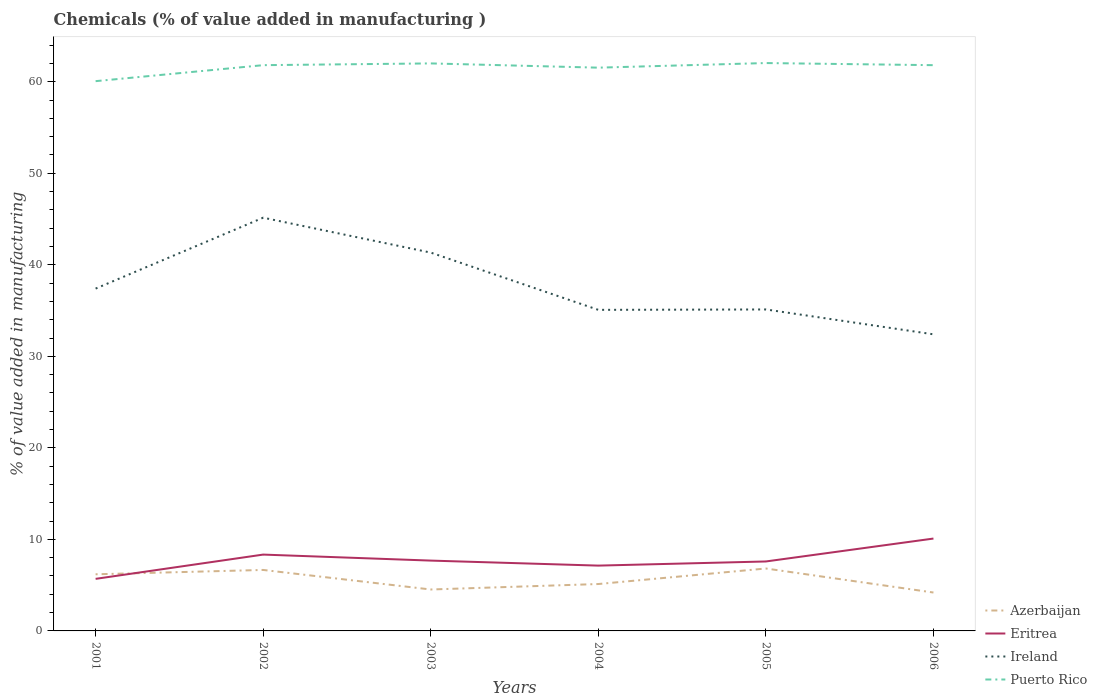How many different coloured lines are there?
Give a very brief answer. 4. Is the number of lines equal to the number of legend labels?
Provide a short and direct response. Yes. Across all years, what is the maximum value added in manufacturing chemicals in Puerto Rico?
Offer a very short reply. 60.06. In which year was the value added in manufacturing chemicals in Puerto Rico maximum?
Offer a terse response. 2001. What is the total value added in manufacturing chemicals in Eritrea in the graph?
Offer a terse response. -2.41. What is the difference between the highest and the second highest value added in manufacturing chemicals in Ireland?
Offer a very short reply. 12.74. Is the value added in manufacturing chemicals in Eritrea strictly greater than the value added in manufacturing chemicals in Ireland over the years?
Offer a terse response. Yes. How many lines are there?
Offer a terse response. 4. Are the values on the major ticks of Y-axis written in scientific E-notation?
Make the answer very short. No. Does the graph contain grids?
Ensure brevity in your answer.  No. Where does the legend appear in the graph?
Your response must be concise. Bottom right. How many legend labels are there?
Make the answer very short. 4. How are the legend labels stacked?
Your response must be concise. Vertical. What is the title of the graph?
Make the answer very short. Chemicals (% of value added in manufacturing ). What is the label or title of the Y-axis?
Give a very brief answer. % of value added in manufacturing. What is the % of value added in manufacturing of Azerbaijan in 2001?
Make the answer very short. 6.19. What is the % of value added in manufacturing in Eritrea in 2001?
Keep it short and to the point. 5.69. What is the % of value added in manufacturing of Ireland in 2001?
Your answer should be very brief. 37.4. What is the % of value added in manufacturing in Puerto Rico in 2001?
Offer a terse response. 60.06. What is the % of value added in manufacturing of Azerbaijan in 2002?
Your answer should be very brief. 6.66. What is the % of value added in manufacturing of Eritrea in 2002?
Give a very brief answer. 8.34. What is the % of value added in manufacturing in Ireland in 2002?
Your answer should be compact. 45.14. What is the % of value added in manufacturing of Puerto Rico in 2002?
Provide a short and direct response. 61.81. What is the % of value added in manufacturing of Azerbaijan in 2003?
Provide a short and direct response. 4.53. What is the % of value added in manufacturing in Eritrea in 2003?
Provide a succinct answer. 7.68. What is the % of value added in manufacturing of Ireland in 2003?
Offer a very short reply. 41.33. What is the % of value added in manufacturing of Puerto Rico in 2003?
Keep it short and to the point. 62. What is the % of value added in manufacturing in Azerbaijan in 2004?
Give a very brief answer. 5.12. What is the % of value added in manufacturing of Eritrea in 2004?
Keep it short and to the point. 7.14. What is the % of value added in manufacturing of Ireland in 2004?
Provide a succinct answer. 35.08. What is the % of value added in manufacturing in Puerto Rico in 2004?
Your answer should be very brief. 61.53. What is the % of value added in manufacturing of Azerbaijan in 2005?
Keep it short and to the point. 6.82. What is the % of value added in manufacturing in Eritrea in 2005?
Provide a short and direct response. 7.59. What is the % of value added in manufacturing in Ireland in 2005?
Ensure brevity in your answer.  35.12. What is the % of value added in manufacturing in Puerto Rico in 2005?
Ensure brevity in your answer.  62.04. What is the % of value added in manufacturing in Azerbaijan in 2006?
Keep it short and to the point. 4.2. What is the % of value added in manufacturing in Eritrea in 2006?
Offer a very short reply. 10.09. What is the % of value added in manufacturing of Ireland in 2006?
Your response must be concise. 32.4. What is the % of value added in manufacturing of Puerto Rico in 2006?
Your response must be concise. 61.81. Across all years, what is the maximum % of value added in manufacturing in Azerbaijan?
Offer a very short reply. 6.82. Across all years, what is the maximum % of value added in manufacturing in Eritrea?
Give a very brief answer. 10.09. Across all years, what is the maximum % of value added in manufacturing in Ireland?
Your response must be concise. 45.14. Across all years, what is the maximum % of value added in manufacturing of Puerto Rico?
Make the answer very short. 62.04. Across all years, what is the minimum % of value added in manufacturing of Azerbaijan?
Give a very brief answer. 4.2. Across all years, what is the minimum % of value added in manufacturing in Eritrea?
Make the answer very short. 5.69. Across all years, what is the minimum % of value added in manufacturing in Ireland?
Make the answer very short. 32.4. Across all years, what is the minimum % of value added in manufacturing in Puerto Rico?
Your answer should be very brief. 60.06. What is the total % of value added in manufacturing in Azerbaijan in the graph?
Your answer should be very brief. 33.51. What is the total % of value added in manufacturing in Eritrea in the graph?
Give a very brief answer. 46.53. What is the total % of value added in manufacturing of Ireland in the graph?
Your response must be concise. 226.47. What is the total % of value added in manufacturing of Puerto Rico in the graph?
Offer a terse response. 369.25. What is the difference between the % of value added in manufacturing in Azerbaijan in 2001 and that in 2002?
Provide a short and direct response. -0.47. What is the difference between the % of value added in manufacturing of Eritrea in 2001 and that in 2002?
Ensure brevity in your answer.  -2.65. What is the difference between the % of value added in manufacturing of Ireland in 2001 and that in 2002?
Keep it short and to the point. -7.75. What is the difference between the % of value added in manufacturing in Puerto Rico in 2001 and that in 2002?
Your answer should be very brief. -1.75. What is the difference between the % of value added in manufacturing of Azerbaijan in 2001 and that in 2003?
Offer a terse response. 1.66. What is the difference between the % of value added in manufacturing of Eritrea in 2001 and that in 2003?
Make the answer very short. -2. What is the difference between the % of value added in manufacturing of Ireland in 2001 and that in 2003?
Offer a terse response. -3.93. What is the difference between the % of value added in manufacturing of Puerto Rico in 2001 and that in 2003?
Give a very brief answer. -1.94. What is the difference between the % of value added in manufacturing of Azerbaijan in 2001 and that in 2004?
Ensure brevity in your answer.  1.06. What is the difference between the % of value added in manufacturing in Eritrea in 2001 and that in 2004?
Your answer should be very brief. -1.45. What is the difference between the % of value added in manufacturing of Ireland in 2001 and that in 2004?
Make the answer very short. 2.32. What is the difference between the % of value added in manufacturing of Puerto Rico in 2001 and that in 2004?
Keep it short and to the point. -1.47. What is the difference between the % of value added in manufacturing of Azerbaijan in 2001 and that in 2005?
Offer a terse response. -0.63. What is the difference between the % of value added in manufacturing of Eritrea in 2001 and that in 2005?
Make the answer very short. -1.9. What is the difference between the % of value added in manufacturing in Ireland in 2001 and that in 2005?
Make the answer very short. 2.28. What is the difference between the % of value added in manufacturing of Puerto Rico in 2001 and that in 2005?
Offer a terse response. -1.98. What is the difference between the % of value added in manufacturing of Azerbaijan in 2001 and that in 2006?
Make the answer very short. 1.99. What is the difference between the % of value added in manufacturing of Eritrea in 2001 and that in 2006?
Offer a terse response. -4.4. What is the difference between the % of value added in manufacturing in Ireland in 2001 and that in 2006?
Keep it short and to the point. 5. What is the difference between the % of value added in manufacturing in Puerto Rico in 2001 and that in 2006?
Provide a short and direct response. -1.75. What is the difference between the % of value added in manufacturing of Azerbaijan in 2002 and that in 2003?
Your response must be concise. 2.14. What is the difference between the % of value added in manufacturing in Eritrea in 2002 and that in 2003?
Offer a terse response. 0.66. What is the difference between the % of value added in manufacturing in Ireland in 2002 and that in 2003?
Keep it short and to the point. 3.81. What is the difference between the % of value added in manufacturing of Puerto Rico in 2002 and that in 2003?
Your answer should be very brief. -0.19. What is the difference between the % of value added in manufacturing in Azerbaijan in 2002 and that in 2004?
Make the answer very short. 1.54. What is the difference between the % of value added in manufacturing of Eritrea in 2002 and that in 2004?
Ensure brevity in your answer.  1.2. What is the difference between the % of value added in manufacturing in Ireland in 2002 and that in 2004?
Make the answer very short. 10.07. What is the difference between the % of value added in manufacturing in Puerto Rico in 2002 and that in 2004?
Your answer should be very brief. 0.27. What is the difference between the % of value added in manufacturing in Azerbaijan in 2002 and that in 2005?
Keep it short and to the point. -0.16. What is the difference between the % of value added in manufacturing of Eritrea in 2002 and that in 2005?
Make the answer very short. 0.75. What is the difference between the % of value added in manufacturing in Ireland in 2002 and that in 2005?
Give a very brief answer. 10.03. What is the difference between the % of value added in manufacturing of Puerto Rico in 2002 and that in 2005?
Give a very brief answer. -0.23. What is the difference between the % of value added in manufacturing in Azerbaijan in 2002 and that in 2006?
Ensure brevity in your answer.  2.47. What is the difference between the % of value added in manufacturing of Eritrea in 2002 and that in 2006?
Provide a succinct answer. -1.75. What is the difference between the % of value added in manufacturing of Ireland in 2002 and that in 2006?
Your answer should be compact. 12.74. What is the difference between the % of value added in manufacturing of Puerto Rico in 2002 and that in 2006?
Provide a succinct answer. 0. What is the difference between the % of value added in manufacturing of Azerbaijan in 2003 and that in 2004?
Give a very brief answer. -0.6. What is the difference between the % of value added in manufacturing in Eritrea in 2003 and that in 2004?
Offer a terse response. 0.55. What is the difference between the % of value added in manufacturing in Ireland in 2003 and that in 2004?
Offer a very short reply. 6.25. What is the difference between the % of value added in manufacturing in Puerto Rico in 2003 and that in 2004?
Your answer should be compact. 0.46. What is the difference between the % of value added in manufacturing in Azerbaijan in 2003 and that in 2005?
Give a very brief answer. -2.29. What is the difference between the % of value added in manufacturing of Eritrea in 2003 and that in 2005?
Make the answer very short. 0.1. What is the difference between the % of value added in manufacturing in Ireland in 2003 and that in 2005?
Your answer should be compact. 6.21. What is the difference between the % of value added in manufacturing of Puerto Rico in 2003 and that in 2005?
Offer a terse response. -0.04. What is the difference between the % of value added in manufacturing of Azerbaijan in 2003 and that in 2006?
Your answer should be compact. 0.33. What is the difference between the % of value added in manufacturing of Eritrea in 2003 and that in 2006?
Provide a succinct answer. -2.41. What is the difference between the % of value added in manufacturing in Ireland in 2003 and that in 2006?
Make the answer very short. 8.93. What is the difference between the % of value added in manufacturing in Puerto Rico in 2003 and that in 2006?
Provide a succinct answer. 0.19. What is the difference between the % of value added in manufacturing of Azerbaijan in 2004 and that in 2005?
Your response must be concise. -1.7. What is the difference between the % of value added in manufacturing in Eritrea in 2004 and that in 2005?
Ensure brevity in your answer.  -0.45. What is the difference between the % of value added in manufacturing in Ireland in 2004 and that in 2005?
Ensure brevity in your answer.  -0.04. What is the difference between the % of value added in manufacturing in Puerto Rico in 2004 and that in 2005?
Ensure brevity in your answer.  -0.5. What is the difference between the % of value added in manufacturing of Azerbaijan in 2004 and that in 2006?
Offer a very short reply. 0.93. What is the difference between the % of value added in manufacturing in Eritrea in 2004 and that in 2006?
Ensure brevity in your answer.  -2.96. What is the difference between the % of value added in manufacturing in Ireland in 2004 and that in 2006?
Your response must be concise. 2.67. What is the difference between the % of value added in manufacturing in Puerto Rico in 2004 and that in 2006?
Make the answer very short. -0.27. What is the difference between the % of value added in manufacturing in Azerbaijan in 2005 and that in 2006?
Your response must be concise. 2.62. What is the difference between the % of value added in manufacturing of Eritrea in 2005 and that in 2006?
Your answer should be compact. -2.5. What is the difference between the % of value added in manufacturing of Ireland in 2005 and that in 2006?
Keep it short and to the point. 2.72. What is the difference between the % of value added in manufacturing in Puerto Rico in 2005 and that in 2006?
Give a very brief answer. 0.23. What is the difference between the % of value added in manufacturing of Azerbaijan in 2001 and the % of value added in manufacturing of Eritrea in 2002?
Your answer should be very brief. -2.15. What is the difference between the % of value added in manufacturing in Azerbaijan in 2001 and the % of value added in manufacturing in Ireland in 2002?
Your response must be concise. -38.96. What is the difference between the % of value added in manufacturing in Azerbaijan in 2001 and the % of value added in manufacturing in Puerto Rico in 2002?
Ensure brevity in your answer.  -55.62. What is the difference between the % of value added in manufacturing of Eritrea in 2001 and the % of value added in manufacturing of Ireland in 2002?
Your answer should be compact. -39.46. What is the difference between the % of value added in manufacturing of Eritrea in 2001 and the % of value added in manufacturing of Puerto Rico in 2002?
Ensure brevity in your answer.  -56.12. What is the difference between the % of value added in manufacturing in Ireland in 2001 and the % of value added in manufacturing in Puerto Rico in 2002?
Provide a short and direct response. -24.41. What is the difference between the % of value added in manufacturing of Azerbaijan in 2001 and the % of value added in manufacturing of Eritrea in 2003?
Provide a short and direct response. -1.5. What is the difference between the % of value added in manufacturing of Azerbaijan in 2001 and the % of value added in manufacturing of Ireland in 2003?
Provide a short and direct response. -35.14. What is the difference between the % of value added in manufacturing of Azerbaijan in 2001 and the % of value added in manufacturing of Puerto Rico in 2003?
Your answer should be compact. -55.81. What is the difference between the % of value added in manufacturing of Eritrea in 2001 and the % of value added in manufacturing of Ireland in 2003?
Your answer should be very brief. -35.64. What is the difference between the % of value added in manufacturing in Eritrea in 2001 and the % of value added in manufacturing in Puerto Rico in 2003?
Provide a succinct answer. -56.31. What is the difference between the % of value added in manufacturing in Ireland in 2001 and the % of value added in manufacturing in Puerto Rico in 2003?
Your response must be concise. -24.6. What is the difference between the % of value added in manufacturing of Azerbaijan in 2001 and the % of value added in manufacturing of Eritrea in 2004?
Offer a very short reply. -0.95. What is the difference between the % of value added in manufacturing in Azerbaijan in 2001 and the % of value added in manufacturing in Ireland in 2004?
Offer a very short reply. -28.89. What is the difference between the % of value added in manufacturing of Azerbaijan in 2001 and the % of value added in manufacturing of Puerto Rico in 2004?
Your answer should be compact. -55.35. What is the difference between the % of value added in manufacturing of Eritrea in 2001 and the % of value added in manufacturing of Ireland in 2004?
Provide a short and direct response. -29.39. What is the difference between the % of value added in manufacturing of Eritrea in 2001 and the % of value added in manufacturing of Puerto Rico in 2004?
Your answer should be compact. -55.85. What is the difference between the % of value added in manufacturing of Ireland in 2001 and the % of value added in manufacturing of Puerto Rico in 2004?
Your answer should be very brief. -24.14. What is the difference between the % of value added in manufacturing of Azerbaijan in 2001 and the % of value added in manufacturing of Eritrea in 2005?
Make the answer very short. -1.4. What is the difference between the % of value added in manufacturing of Azerbaijan in 2001 and the % of value added in manufacturing of Ireland in 2005?
Your answer should be very brief. -28.93. What is the difference between the % of value added in manufacturing in Azerbaijan in 2001 and the % of value added in manufacturing in Puerto Rico in 2005?
Your answer should be very brief. -55.85. What is the difference between the % of value added in manufacturing in Eritrea in 2001 and the % of value added in manufacturing in Ireland in 2005?
Your response must be concise. -29.43. What is the difference between the % of value added in manufacturing in Eritrea in 2001 and the % of value added in manufacturing in Puerto Rico in 2005?
Give a very brief answer. -56.35. What is the difference between the % of value added in manufacturing of Ireland in 2001 and the % of value added in manufacturing of Puerto Rico in 2005?
Your response must be concise. -24.64. What is the difference between the % of value added in manufacturing in Azerbaijan in 2001 and the % of value added in manufacturing in Eritrea in 2006?
Make the answer very short. -3.9. What is the difference between the % of value added in manufacturing of Azerbaijan in 2001 and the % of value added in manufacturing of Ireland in 2006?
Ensure brevity in your answer.  -26.21. What is the difference between the % of value added in manufacturing of Azerbaijan in 2001 and the % of value added in manufacturing of Puerto Rico in 2006?
Make the answer very short. -55.62. What is the difference between the % of value added in manufacturing of Eritrea in 2001 and the % of value added in manufacturing of Ireland in 2006?
Your answer should be compact. -26.71. What is the difference between the % of value added in manufacturing of Eritrea in 2001 and the % of value added in manufacturing of Puerto Rico in 2006?
Offer a terse response. -56.12. What is the difference between the % of value added in manufacturing in Ireland in 2001 and the % of value added in manufacturing in Puerto Rico in 2006?
Offer a terse response. -24.41. What is the difference between the % of value added in manufacturing in Azerbaijan in 2002 and the % of value added in manufacturing in Eritrea in 2003?
Provide a short and direct response. -1.02. What is the difference between the % of value added in manufacturing of Azerbaijan in 2002 and the % of value added in manufacturing of Ireland in 2003?
Ensure brevity in your answer.  -34.67. What is the difference between the % of value added in manufacturing in Azerbaijan in 2002 and the % of value added in manufacturing in Puerto Rico in 2003?
Your answer should be very brief. -55.34. What is the difference between the % of value added in manufacturing in Eritrea in 2002 and the % of value added in manufacturing in Ireland in 2003?
Provide a succinct answer. -32.99. What is the difference between the % of value added in manufacturing of Eritrea in 2002 and the % of value added in manufacturing of Puerto Rico in 2003?
Provide a short and direct response. -53.66. What is the difference between the % of value added in manufacturing in Ireland in 2002 and the % of value added in manufacturing in Puerto Rico in 2003?
Offer a very short reply. -16.85. What is the difference between the % of value added in manufacturing of Azerbaijan in 2002 and the % of value added in manufacturing of Eritrea in 2004?
Your response must be concise. -0.47. What is the difference between the % of value added in manufacturing of Azerbaijan in 2002 and the % of value added in manufacturing of Ireland in 2004?
Provide a succinct answer. -28.41. What is the difference between the % of value added in manufacturing of Azerbaijan in 2002 and the % of value added in manufacturing of Puerto Rico in 2004?
Give a very brief answer. -54.87. What is the difference between the % of value added in manufacturing in Eritrea in 2002 and the % of value added in manufacturing in Ireland in 2004?
Ensure brevity in your answer.  -26.74. What is the difference between the % of value added in manufacturing of Eritrea in 2002 and the % of value added in manufacturing of Puerto Rico in 2004?
Make the answer very short. -53.2. What is the difference between the % of value added in manufacturing of Ireland in 2002 and the % of value added in manufacturing of Puerto Rico in 2004?
Your answer should be compact. -16.39. What is the difference between the % of value added in manufacturing in Azerbaijan in 2002 and the % of value added in manufacturing in Eritrea in 2005?
Ensure brevity in your answer.  -0.93. What is the difference between the % of value added in manufacturing in Azerbaijan in 2002 and the % of value added in manufacturing in Ireland in 2005?
Ensure brevity in your answer.  -28.46. What is the difference between the % of value added in manufacturing in Azerbaijan in 2002 and the % of value added in manufacturing in Puerto Rico in 2005?
Offer a very short reply. -55.38. What is the difference between the % of value added in manufacturing in Eritrea in 2002 and the % of value added in manufacturing in Ireland in 2005?
Ensure brevity in your answer.  -26.78. What is the difference between the % of value added in manufacturing in Eritrea in 2002 and the % of value added in manufacturing in Puerto Rico in 2005?
Ensure brevity in your answer.  -53.7. What is the difference between the % of value added in manufacturing in Ireland in 2002 and the % of value added in manufacturing in Puerto Rico in 2005?
Ensure brevity in your answer.  -16.89. What is the difference between the % of value added in manufacturing in Azerbaijan in 2002 and the % of value added in manufacturing in Eritrea in 2006?
Keep it short and to the point. -3.43. What is the difference between the % of value added in manufacturing in Azerbaijan in 2002 and the % of value added in manufacturing in Ireland in 2006?
Provide a succinct answer. -25.74. What is the difference between the % of value added in manufacturing in Azerbaijan in 2002 and the % of value added in manufacturing in Puerto Rico in 2006?
Ensure brevity in your answer.  -55.15. What is the difference between the % of value added in manufacturing in Eritrea in 2002 and the % of value added in manufacturing in Ireland in 2006?
Give a very brief answer. -24.06. What is the difference between the % of value added in manufacturing of Eritrea in 2002 and the % of value added in manufacturing of Puerto Rico in 2006?
Provide a short and direct response. -53.47. What is the difference between the % of value added in manufacturing of Ireland in 2002 and the % of value added in manufacturing of Puerto Rico in 2006?
Make the answer very short. -16.66. What is the difference between the % of value added in manufacturing of Azerbaijan in 2003 and the % of value added in manufacturing of Eritrea in 2004?
Offer a terse response. -2.61. What is the difference between the % of value added in manufacturing in Azerbaijan in 2003 and the % of value added in manufacturing in Ireland in 2004?
Provide a succinct answer. -30.55. What is the difference between the % of value added in manufacturing of Azerbaijan in 2003 and the % of value added in manufacturing of Puerto Rico in 2004?
Your answer should be very brief. -57.01. What is the difference between the % of value added in manufacturing in Eritrea in 2003 and the % of value added in manufacturing in Ireland in 2004?
Provide a succinct answer. -27.39. What is the difference between the % of value added in manufacturing in Eritrea in 2003 and the % of value added in manufacturing in Puerto Rico in 2004?
Keep it short and to the point. -53.85. What is the difference between the % of value added in manufacturing in Ireland in 2003 and the % of value added in manufacturing in Puerto Rico in 2004?
Provide a short and direct response. -20.2. What is the difference between the % of value added in manufacturing in Azerbaijan in 2003 and the % of value added in manufacturing in Eritrea in 2005?
Provide a succinct answer. -3.06. What is the difference between the % of value added in manufacturing in Azerbaijan in 2003 and the % of value added in manufacturing in Ireland in 2005?
Your answer should be very brief. -30.59. What is the difference between the % of value added in manufacturing in Azerbaijan in 2003 and the % of value added in manufacturing in Puerto Rico in 2005?
Offer a very short reply. -57.51. What is the difference between the % of value added in manufacturing of Eritrea in 2003 and the % of value added in manufacturing of Ireland in 2005?
Ensure brevity in your answer.  -27.44. What is the difference between the % of value added in manufacturing in Eritrea in 2003 and the % of value added in manufacturing in Puerto Rico in 2005?
Your answer should be compact. -54.35. What is the difference between the % of value added in manufacturing of Ireland in 2003 and the % of value added in manufacturing of Puerto Rico in 2005?
Offer a very short reply. -20.71. What is the difference between the % of value added in manufacturing in Azerbaijan in 2003 and the % of value added in manufacturing in Eritrea in 2006?
Your answer should be very brief. -5.57. What is the difference between the % of value added in manufacturing in Azerbaijan in 2003 and the % of value added in manufacturing in Ireland in 2006?
Provide a short and direct response. -27.88. What is the difference between the % of value added in manufacturing in Azerbaijan in 2003 and the % of value added in manufacturing in Puerto Rico in 2006?
Ensure brevity in your answer.  -57.28. What is the difference between the % of value added in manufacturing in Eritrea in 2003 and the % of value added in manufacturing in Ireland in 2006?
Make the answer very short. -24.72. What is the difference between the % of value added in manufacturing in Eritrea in 2003 and the % of value added in manufacturing in Puerto Rico in 2006?
Offer a terse response. -54.12. What is the difference between the % of value added in manufacturing of Ireland in 2003 and the % of value added in manufacturing of Puerto Rico in 2006?
Your answer should be compact. -20.48. What is the difference between the % of value added in manufacturing in Azerbaijan in 2004 and the % of value added in manufacturing in Eritrea in 2005?
Give a very brief answer. -2.46. What is the difference between the % of value added in manufacturing in Azerbaijan in 2004 and the % of value added in manufacturing in Ireland in 2005?
Keep it short and to the point. -30. What is the difference between the % of value added in manufacturing of Azerbaijan in 2004 and the % of value added in manufacturing of Puerto Rico in 2005?
Your answer should be compact. -56.92. What is the difference between the % of value added in manufacturing of Eritrea in 2004 and the % of value added in manufacturing of Ireland in 2005?
Your answer should be compact. -27.98. What is the difference between the % of value added in manufacturing of Eritrea in 2004 and the % of value added in manufacturing of Puerto Rico in 2005?
Your answer should be very brief. -54.9. What is the difference between the % of value added in manufacturing in Ireland in 2004 and the % of value added in manufacturing in Puerto Rico in 2005?
Give a very brief answer. -26.96. What is the difference between the % of value added in manufacturing in Azerbaijan in 2004 and the % of value added in manufacturing in Eritrea in 2006?
Offer a terse response. -4.97. What is the difference between the % of value added in manufacturing of Azerbaijan in 2004 and the % of value added in manufacturing of Ireland in 2006?
Your answer should be compact. -27.28. What is the difference between the % of value added in manufacturing of Azerbaijan in 2004 and the % of value added in manufacturing of Puerto Rico in 2006?
Make the answer very short. -56.68. What is the difference between the % of value added in manufacturing of Eritrea in 2004 and the % of value added in manufacturing of Ireland in 2006?
Give a very brief answer. -25.27. What is the difference between the % of value added in manufacturing in Eritrea in 2004 and the % of value added in manufacturing in Puerto Rico in 2006?
Your response must be concise. -54.67. What is the difference between the % of value added in manufacturing of Ireland in 2004 and the % of value added in manufacturing of Puerto Rico in 2006?
Give a very brief answer. -26.73. What is the difference between the % of value added in manufacturing of Azerbaijan in 2005 and the % of value added in manufacturing of Eritrea in 2006?
Provide a short and direct response. -3.27. What is the difference between the % of value added in manufacturing in Azerbaijan in 2005 and the % of value added in manufacturing in Ireland in 2006?
Your answer should be compact. -25.58. What is the difference between the % of value added in manufacturing of Azerbaijan in 2005 and the % of value added in manufacturing of Puerto Rico in 2006?
Your answer should be very brief. -54.99. What is the difference between the % of value added in manufacturing in Eritrea in 2005 and the % of value added in manufacturing in Ireland in 2006?
Give a very brief answer. -24.81. What is the difference between the % of value added in manufacturing in Eritrea in 2005 and the % of value added in manufacturing in Puerto Rico in 2006?
Your answer should be compact. -54.22. What is the difference between the % of value added in manufacturing of Ireland in 2005 and the % of value added in manufacturing of Puerto Rico in 2006?
Provide a succinct answer. -26.69. What is the average % of value added in manufacturing of Azerbaijan per year?
Your answer should be compact. 5.59. What is the average % of value added in manufacturing in Eritrea per year?
Keep it short and to the point. 7.75. What is the average % of value added in manufacturing of Ireland per year?
Your response must be concise. 37.75. What is the average % of value added in manufacturing in Puerto Rico per year?
Your answer should be very brief. 61.54. In the year 2001, what is the difference between the % of value added in manufacturing in Azerbaijan and % of value added in manufacturing in Eritrea?
Keep it short and to the point. 0.5. In the year 2001, what is the difference between the % of value added in manufacturing of Azerbaijan and % of value added in manufacturing of Ireland?
Your response must be concise. -31.21. In the year 2001, what is the difference between the % of value added in manufacturing of Azerbaijan and % of value added in manufacturing of Puerto Rico?
Provide a succinct answer. -53.87. In the year 2001, what is the difference between the % of value added in manufacturing in Eritrea and % of value added in manufacturing in Ireland?
Offer a terse response. -31.71. In the year 2001, what is the difference between the % of value added in manufacturing in Eritrea and % of value added in manufacturing in Puerto Rico?
Give a very brief answer. -54.37. In the year 2001, what is the difference between the % of value added in manufacturing of Ireland and % of value added in manufacturing of Puerto Rico?
Offer a terse response. -22.66. In the year 2002, what is the difference between the % of value added in manufacturing of Azerbaijan and % of value added in manufacturing of Eritrea?
Give a very brief answer. -1.68. In the year 2002, what is the difference between the % of value added in manufacturing in Azerbaijan and % of value added in manufacturing in Ireland?
Provide a succinct answer. -38.48. In the year 2002, what is the difference between the % of value added in manufacturing in Azerbaijan and % of value added in manufacturing in Puerto Rico?
Offer a very short reply. -55.15. In the year 2002, what is the difference between the % of value added in manufacturing of Eritrea and % of value added in manufacturing of Ireland?
Make the answer very short. -36.8. In the year 2002, what is the difference between the % of value added in manufacturing in Eritrea and % of value added in manufacturing in Puerto Rico?
Provide a short and direct response. -53.47. In the year 2002, what is the difference between the % of value added in manufacturing in Ireland and % of value added in manufacturing in Puerto Rico?
Your answer should be very brief. -16.66. In the year 2003, what is the difference between the % of value added in manufacturing of Azerbaijan and % of value added in manufacturing of Eritrea?
Make the answer very short. -3.16. In the year 2003, what is the difference between the % of value added in manufacturing of Azerbaijan and % of value added in manufacturing of Ireland?
Provide a short and direct response. -36.8. In the year 2003, what is the difference between the % of value added in manufacturing of Azerbaijan and % of value added in manufacturing of Puerto Rico?
Make the answer very short. -57.47. In the year 2003, what is the difference between the % of value added in manufacturing of Eritrea and % of value added in manufacturing of Ireland?
Make the answer very short. -33.65. In the year 2003, what is the difference between the % of value added in manufacturing in Eritrea and % of value added in manufacturing in Puerto Rico?
Provide a short and direct response. -54.32. In the year 2003, what is the difference between the % of value added in manufacturing of Ireland and % of value added in manufacturing of Puerto Rico?
Offer a very short reply. -20.67. In the year 2004, what is the difference between the % of value added in manufacturing in Azerbaijan and % of value added in manufacturing in Eritrea?
Provide a short and direct response. -2.01. In the year 2004, what is the difference between the % of value added in manufacturing of Azerbaijan and % of value added in manufacturing of Ireland?
Provide a short and direct response. -29.95. In the year 2004, what is the difference between the % of value added in manufacturing of Azerbaijan and % of value added in manufacturing of Puerto Rico?
Your answer should be very brief. -56.41. In the year 2004, what is the difference between the % of value added in manufacturing in Eritrea and % of value added in manufacturing in Ireland?
Keep it short and to the point. -27.94. In the year 2004, what is the difference between the % of value added in manufacturing in Eritrea and % of value added in manufacturing in Puerto Rico?
Offer a very short reply. -54.4. In the year 2004, what is the difference between the % of value added in manufacturing in Ireland and % of value added in manufacturing in Puerto Rico?
Keep it short and to the point. -26.46. In the year 2005, what is the difference between the % of value added in manufacturing of Azerbaijan and % of value added in manufacturing of Eritrea?
Your response must be concise. -0.77. In the year 2005, what is the difference between the % of value added in manufacturing of Azerbaijan and % of value added in manufacturing of Ireland?
Ensure brevity in your answer.  -28.3. In the year 2005, what is the difference between the % of value added in manufacturing in Azerbaijan and % of value added in manufacturing in Puerto Rico?
Provide a short and direct response. -55.22. In the year 2005, what is the difference between the % of value added in manufacturing in Eritrea and % of value added in manufacturing in Ireland?
Make the answer very short. -27.53. In the year 2005, what is the difference between the % of value added in manufacturing of Eritrea and % of value added in manufacturing of Puerto Rico?
Ensure brevity in your answer.  -54.45. In the year 2005, what is the difference between the % of value added in manufacturing in Ireland and % of value added in manufacturing in Puerto Rico?
Make the answer very short. -26.92. In the year 2006, what is the difference between the % of value added in manufacturing of Azerbaijan and % of value added in manufacturing of Eritrea?
Keep it short and to the point. -5.9. In the year 2006, what is the difference between the % of value added in manufacturing of Azerbaijan and % of value added in manufacturing of Ireland?
Offer a very short reply. -28.21. In the year 2006, what is the difference between the % of value added in manufacturing of Azerbaijan and % of value added in manufacturing of Puerto Rico?
Keep it short and to the point. -57.61. In the year 2006, what is the difference between the % of value added in manufacturing in Eritrea and % of value added in manufacturing in Ireland?
Ensure brevity in your answer.  -22.31. In the year 2006, what is the difference between the % of value added in manufacturing of Eritrea and % of value added in manufacturing of Puerto Rico?
Offer a terse response. -51.72. In the year 2006, what is the difference between the % of value added in manufacturing of Ireland and % of value added in manufacturing of Puerto Rico?
Your answer should be very brief. -29.4. What is the ratio of the % of value added in manufacturing in Azerbaijan in 2001 to that in 2002?
Offer a very short reply. 0.93. What is the ratio of the % of value added in manufacturing of Eritrea in 2001 to that in 2002?
Your answer should be compact. 0.68. What is the ratio of the % of value added in manufacturing in Ireland in 2001 to that in 2002?
Provide a succinct answer. 0.83. What is the ratio of the % of value added in manufacturing of Puerto Rico in 2001 to that in 2002?
Your answer should be compact. 0.97. What is the ratio of the % of value added in manufacturing of Azerbaijan in 2001 to that in 2003?
Offer a terse response. 1.37. What is the ratio of the % of value added in manufacturing in Eritrea in 2001 to that in 2003?
Offer a very short reply. 0.74. What is the ratio of the % of value added in manufacturing of Ireland in 2001 to that in 2003?
Your answer should be very brief. 0.9. What is the ratio of the % of value added in manufacturing in Puerto Rico in 2001 to that in 2003?
Offer a terse response. 0.97. What is the ratio of the % of value added in manufacturing in Azerbaijan in 2001 to that in 2004?
Your answer should be compact. 1.21. What is the ratio of the % of value added in manufacturing in Eritrea in 2001 to that in 2004?
Ensure brevity in your answer.  0.8. What is the ratio of the % of value added in manufacturing of Ireland in 2001 to that in 2004?
Provide a succinct answer. 1.07. What is the ratio of the % of value added in manufacturing in Azerbaijan in 2001 to that in 2005?
Ensure brevity in your answer.  0.91. What is the ratio of the % of value added in manufacturing of Eritrea in 2001 to that in 2005?
Offer a terse response. 0.75. What is the ratio of the % of value added in manufacturing in Ireland in 2001 to that in 2005?
Keep it short and to the point. 1.06. What is the ratio of the % of value added in manufacturing in Puerto Rico in 2001 to that in 2005?
Your answer should be very brief. 0.97. What is the ratio of the % of value added in manufacturing of Azerbaijan in 2001 to that in 2006?
Your answer should be compact. 1.47. What is the ratio of the % of value added in manufacturing in Eritrea in 2001 to that in 2006?
Your response must be concise. 0.56. What is the ratio of the % of value added in manufacturing in Ireland in 2001 to that in 2006?
Give a very brief answer. 1.15. What is the ratio of the % of value added in manufacturing of Puerto Rico in 2001 to that in 2006?
Ensure brevity in your answer.  0.97. What is the ratio of the % of value added in manufacturing in Azerbaijan in 2002 to that in 2003?
Provide a short and direct response. 1.47. What is the ratio of the % of value added in manufacturing of Eritrea in 2002 to that in 2003?
Your response must be concise. 1.09. What is the ratio of the % of value added in manufacturing of Ireland in 2002 to that in 2003?
Ensure brevity in your answer.  1.09. What is the ratio of the % of value added in manufacturing in Azerbaijan in 2002 to that in 2004?
Offer a terse response. 1.3. What is the ratio of the % of value added in manufacturing of Eritrea in 2002 to that in 2004?
Offer a very short reply. 1.17. What is the ratio of the % of value added in manufacturing of Ireland in 2002 to that in 2004?
Make the answer very short. 1.29. What is the ratio of the % of value added in manufacturing in Azerbaijan in 2002 to that in 2005?
Offer a terse response. 0.98. What is the ratio of the % of value added in manufacturing of Eritrea in 2002 to that in 2005?
Make the answer very short. 1.1. What is the ratio of the % of value added in manufacturing in Ireland in 2002 to that in 2005?
Offer a terse response. 1.29. What is the ratio of the % of value added in manufacturing in Puerto Rico in 2002 to that in 2005?
Offer a terse response. 1. What is the ratio of the % of value added in manufacturing of Azerbaijan in 2002 to that in 2006?
Keep it short and to the point. 1.59. What is the ratio of the % of value added in manufacturing in Eritrea in 2002 to that in 2006?
Keep it short and to the point. 0.83. What is the ratio of the % of value added in manufacturing in Ireland in 2002 to that in 2006?
Offer a terse response. 1.39. What is the ratio of the % of value added in manufacturing of Puerto Rico in 2002 to that in 2006?
Give a very brief answer. 1. What is the ratio of the % of value added in manufacturing of Azerbaijan in 2003 to that in 2004?
Your answer should be compact. 0.88. What is the ratio of the % of value added in manufacturing in Eritrea in 2003 to that in 2004?
Give a very brief answer. 1.08. What is the ratio of the % of value added in manufacturing of Ireland in 2003 to that in 2004?
Keep it short and to the point. 1.18. What is the ratio of the % of value added in manufacturing of Puerto Rico in 2003 to that in 2004?
Offer a terse response. 1.01. What is the ratio of the % of value added in manufacturing of Azerbaijan in 2003 to that in 2005?
Provide a succinct answer. 0.66. What is the ratio of the % of value added in manufacturing in Eritrea in 2003 to that in 2005?
Offer a terse response. 1.01. What is the ratio of the % of value added in manufacturing of Ireland in 2003 to that in 2005?
Offer a terse response. 1.18. What is the ratio of the % of value added in manufacturing in Puerto Rico in 2003 to that in 2005?
Offer a very short reply. 1. What is the ratio of the % of value added in manufacturing in Azerbaijan in 2003 to that in 2006?
Provide a succinct answer. 1.08. What is the ratio of the % of value added in manufacturing of Eritrea in 2003 to that in 2006?
Provide a short and direct response. 0.76. What is the ratio of the % of value added in manufacturing of Ireland in 2003 to that in 2006?
Offer a terse response. 1.28. What is the ratio of the % of value added in manufacturing in Puerto Rico in 2003 to that in 2006?
Keep it short and to the point. 1. What is the ratio of the % of value added in manufacturing of Azerbaijan in 2004 to that in 2005?
Your answer should be compact. 0.75. What is the ratio of the % of value added in manufacturing of Eritrea in 2004 to that in 2005?
Offer a very short reply. 0.94. What is the ratio of the % of value added in manufacturing in Puerto Rico in 2004 to that in 2005?
Offer a terse response. 0.99. What is the ratio of the % of value added in manufacturing in Azerbaijan in 2004 to that in 2006?
Your response must be concise. 1.22. What is the ratio of the % of value added in manufacturing of Eritrea in 2004 to that in 2006?
Keep it short and to the point. 0.71. What is the ratio of the % of value added in manufacturing in Ireland in 2004 to that in 2006?
Keep it short and to the point. 1.08. What is the ratio of the % of value added in manufacturing in Azerbaijan in 2005 to that in 2006?
Your response must be concise. 1.63. What is the ratio of the % of value added in manufacturing in Eritrea in 2005 to that in 2006?
Offer a very short reply. 0.75. What is the ratio of the % of value added in manufacturing of Ireland in 2005 to that in 2006?
Your answer should be compact. 1.08. What is the difference between the highest and the second highest % of value added in manufacturing of Azerbaijan?
Offer a terse response. 0.16. What is the difference between the highest and the second highest % of value added in manufacturing of Eritrea?
Ensure brevity in your answer.  1.75. What is the difference between the highest and the second highest % of value added in manufacturing in Ireland?
Your response must be concise. 3.81. What is the difference between the highest and the second highest % of value added in manufacturing in Puerto Rico?
Your response must be concise. 0.04. What is the difference between the highest and the lowest % of value added in manufacturing of Azerbaijan?
Offer a terse response. 2.62. What is the difference between the highest and the lowest % of value added in manufacturing of Eritrea?
Provide a short and direct response. 4.4. What is the difference between the highest and the lowest % of value added in manufacturing of Ireland?
Give a very brief answer. 12.74. What is the difference between the highest and the lowest % of value added in manufacturing in Puerto Rico?
Give a very brief answer. 1.98. 